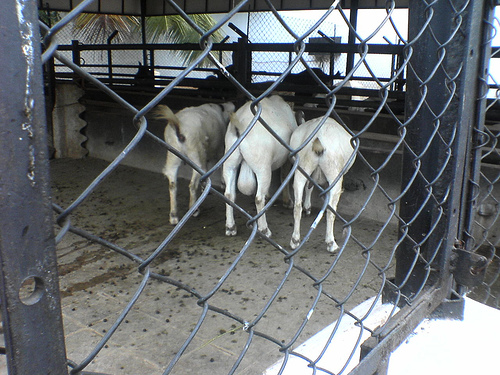<image>
Is there a fence behind the cow? Yes. From this viewpoint, the fence is positioned behind the cow, with the cow partially or fully occluding the fence. Is the gates on the animal? No. The gates is not positioned on the animal. They may be near each other, but the gates is not supported by or resting on top of the animal. Where is the fence in relation to the goat? Is it in front of the goat? Yes. The fence is positioned in front of the goat, appearing closer to the camera viewpoint. 